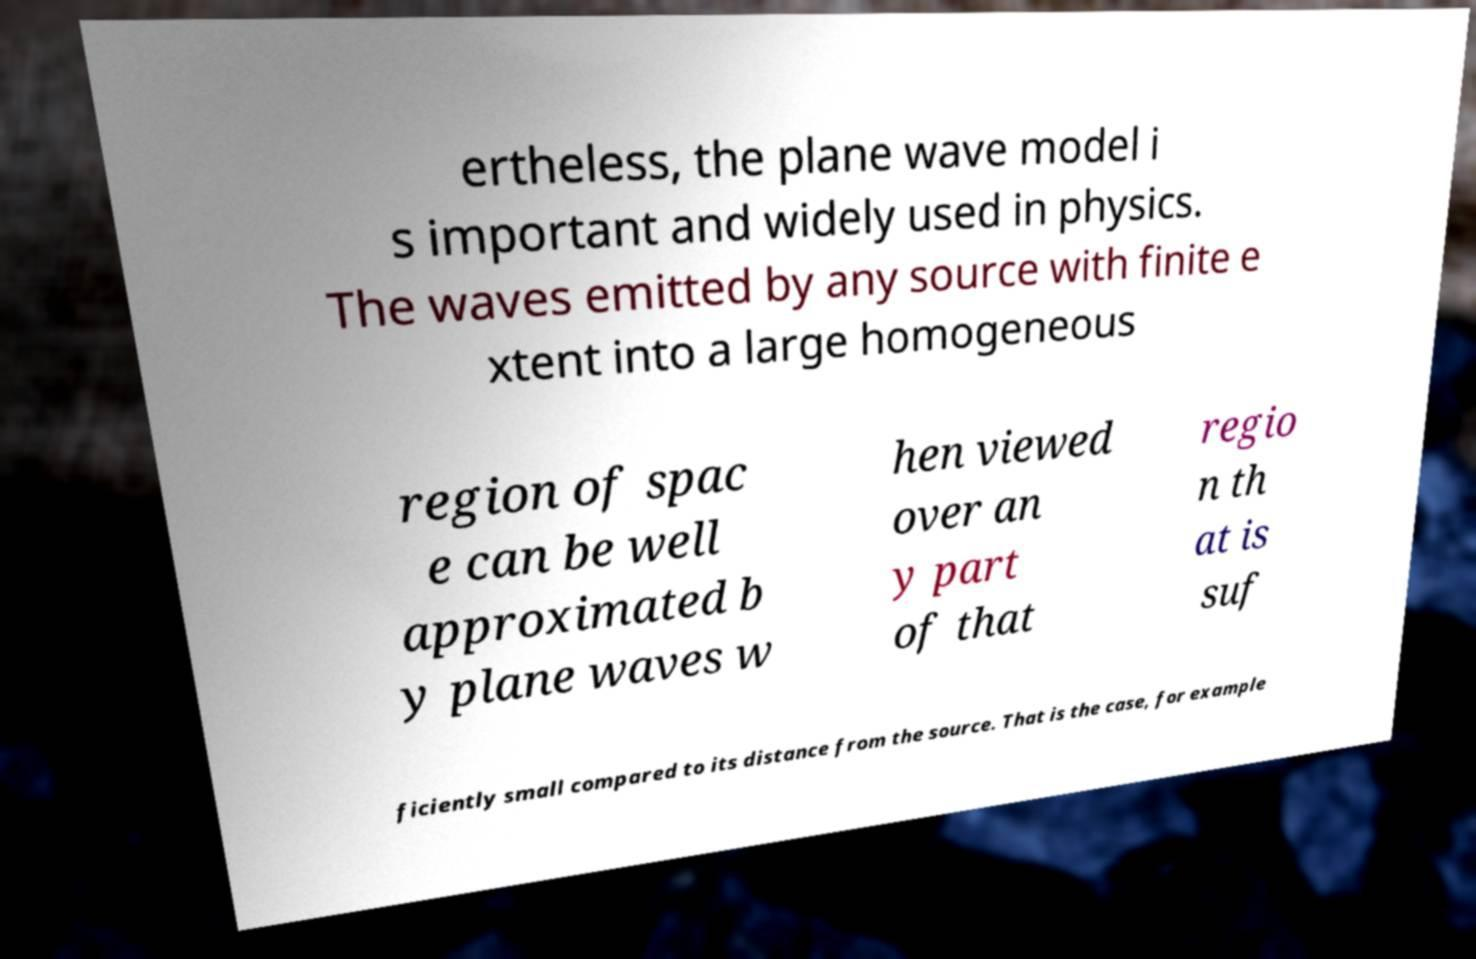What messages or text are displayed in this image? I need them in a readable, typed format. ertheless, the plane wave model i s important and widely used in physics. The waves emitted by any source with finite e xtent into a large homogeneous region of spac e can be well approximated b y plane waves w hen viewed over an y part of that regio n th at is suf ficiently small compared to its distance from the source. That is the case, for example 